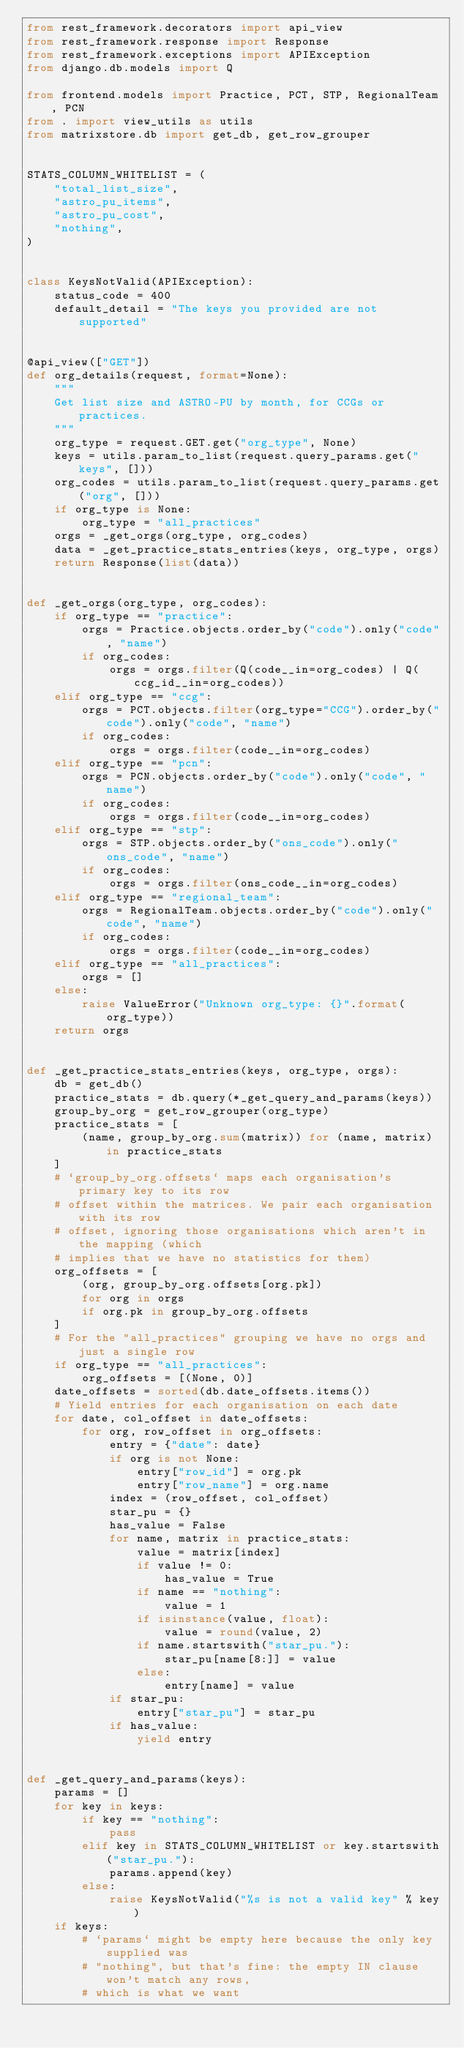Convert code to text. <code><loc_0><loc_0><loc_500><loc_500><_Python_>from rest_framework.decorators import api_view
from rest_framework.response import Response
from rest_framework.exceptions import APIException
from django.db.models import Q

from frontend.models import Practice, PCT, STP, RegionalTeam, PCN
from . import view_utils as utils
from matrixstore.db import get_db, get_row_grouper


STATS_COLUMN_WHITELIST = (
    "total_list_size",
    "astro_pu_items",
    "astro_pu_cost",
    "nothing",
)


class KeysNotValid(APIException):
    status_code = 400
    default_detail = "The keys you provided are not supported"


@api_view(["GET"])
def org_details(request, format=None):
    """
    Get list size and ASTRO-PU by month, for CCGs or practices.
    """
    org_type = request.GET.get("org_type", None)
    keys = utils.param_to_list(request.query_params.get("keys", []))
    org_codes = utils.param_to_list(request.query_params.get("org", []))
    if org_type is None:
        org_type = "all_practices"
    orgs = _get_orgs(org_type, org_codes)
    data = _get_practice_stats_entries(keys, org_type, orgs)
    return Response(list(data))


def _get_orgs(org_type, org_codes):
    if org_type == "practice":
        orgs = Practice.objects.order_by("code").only("code", "name")
        if org_codes:
            orgs = orgs.filter(Q(code__in=org_codes) | Q(ccg_id__in=org_codes))
    elif org_type == "ccg":
        orgs = PCT.objects.filter(org_type="CCG").order_by("code").only("code", "name")
        if org_codes:
            orgs = orgs.filter(code__in=org_codes)
    elif org_type == "pcn":
        orgs = PCN.objects.order_by("code").only("code", "name")
        if org_codes:
            orgs = orgs.filter(code__in=org_codes)
    elif org_type == "stp":
        orgs = STP.objects.order_by("ons_code").only("ons_code", "name")
        if org_codes:
            orgs = orgs.filter(ons_code__in=org_codes)
    elif org_type == "regional_team":
        orgs = RegionalTeam.objects.order_by("code").only("code", "name")
        if org_codes:
            orgs = orgs.filter(code__in=org_codes)
    elif org_type == "all_practices":
        orgs = []
    else:
        raise ValueError("Unknown org_type: {}".format(org_type))
    return orgs


def _get_practice_stats_entries(keys, org_type, orgs):
    db = get_db()
    practice_stats = db.query(*_get_query_and_params(keys))
    group_by_org = get_row_grouper(org_type)
    practice_stats = [
        (name, group_by_org.sum(matrix)) for (name, matrix) in practice_stats
    ]
    # `group_by_org.offsets` maps each organisation's primary key to its row
    # offset within the matrices. We pair each organisation with its row
    # offset, ignoring those organisations which aren't in the mapping (which
    # implies that we have no statistics for them)
    org_offsets = [
        (org, group_by_org.offsets[org.pk])
        for org in orgs
        if org.pk in group_by_org.offsets
    ]
    # For the "all_practices" grouping we have no orgs and just a single row
    if org_type == "all_practices":
        org_offsets = [(None, 0)]
    date_offsets = sorted(db.date_offsets.items())
    # Yield entries for each organisation on each date
    for date, col_offset in date_offsets:
        for org, row_offset in org_offsets:
            entry = {"date": date}
            if org is not None:
                entry["row_id"] = org.pk
                entry["row_name"] = org.name
            index = (row_offset, col_offset)
            star_pu = {}
            has_value = False
            for name, matrix in practice_stats:
                value = matrix[index]
                if value != 0:
                    has_value = True
                if name == "nothing":
                    value = 1
                if isinstance(value, float):
                    value = round(value, 2)
                if name.startswith("star_pu."):
                    star_pu[name[8:]] = value
                else:
                    entry[name] = value
            if star_pu:
                entry["star_pu"] = star_pu
            if has_value:
                yield entry


def _get_query_and_params(keys):
    params = []
    for key in keys:
        if key == "nothing":
            pass
        elif key in STATS_COLUMN_WHITELIST or key.startswith("star_pu."):
            params.append(key)
        else:
            raise KeysNotValid("%s is not a valid key" % key)
    if keys:
        # `params` might be empty here because the only key supplied was
        # "nothing", but that's fine: the empty IN clause won't match any rows,
        # which is what we want</code> 